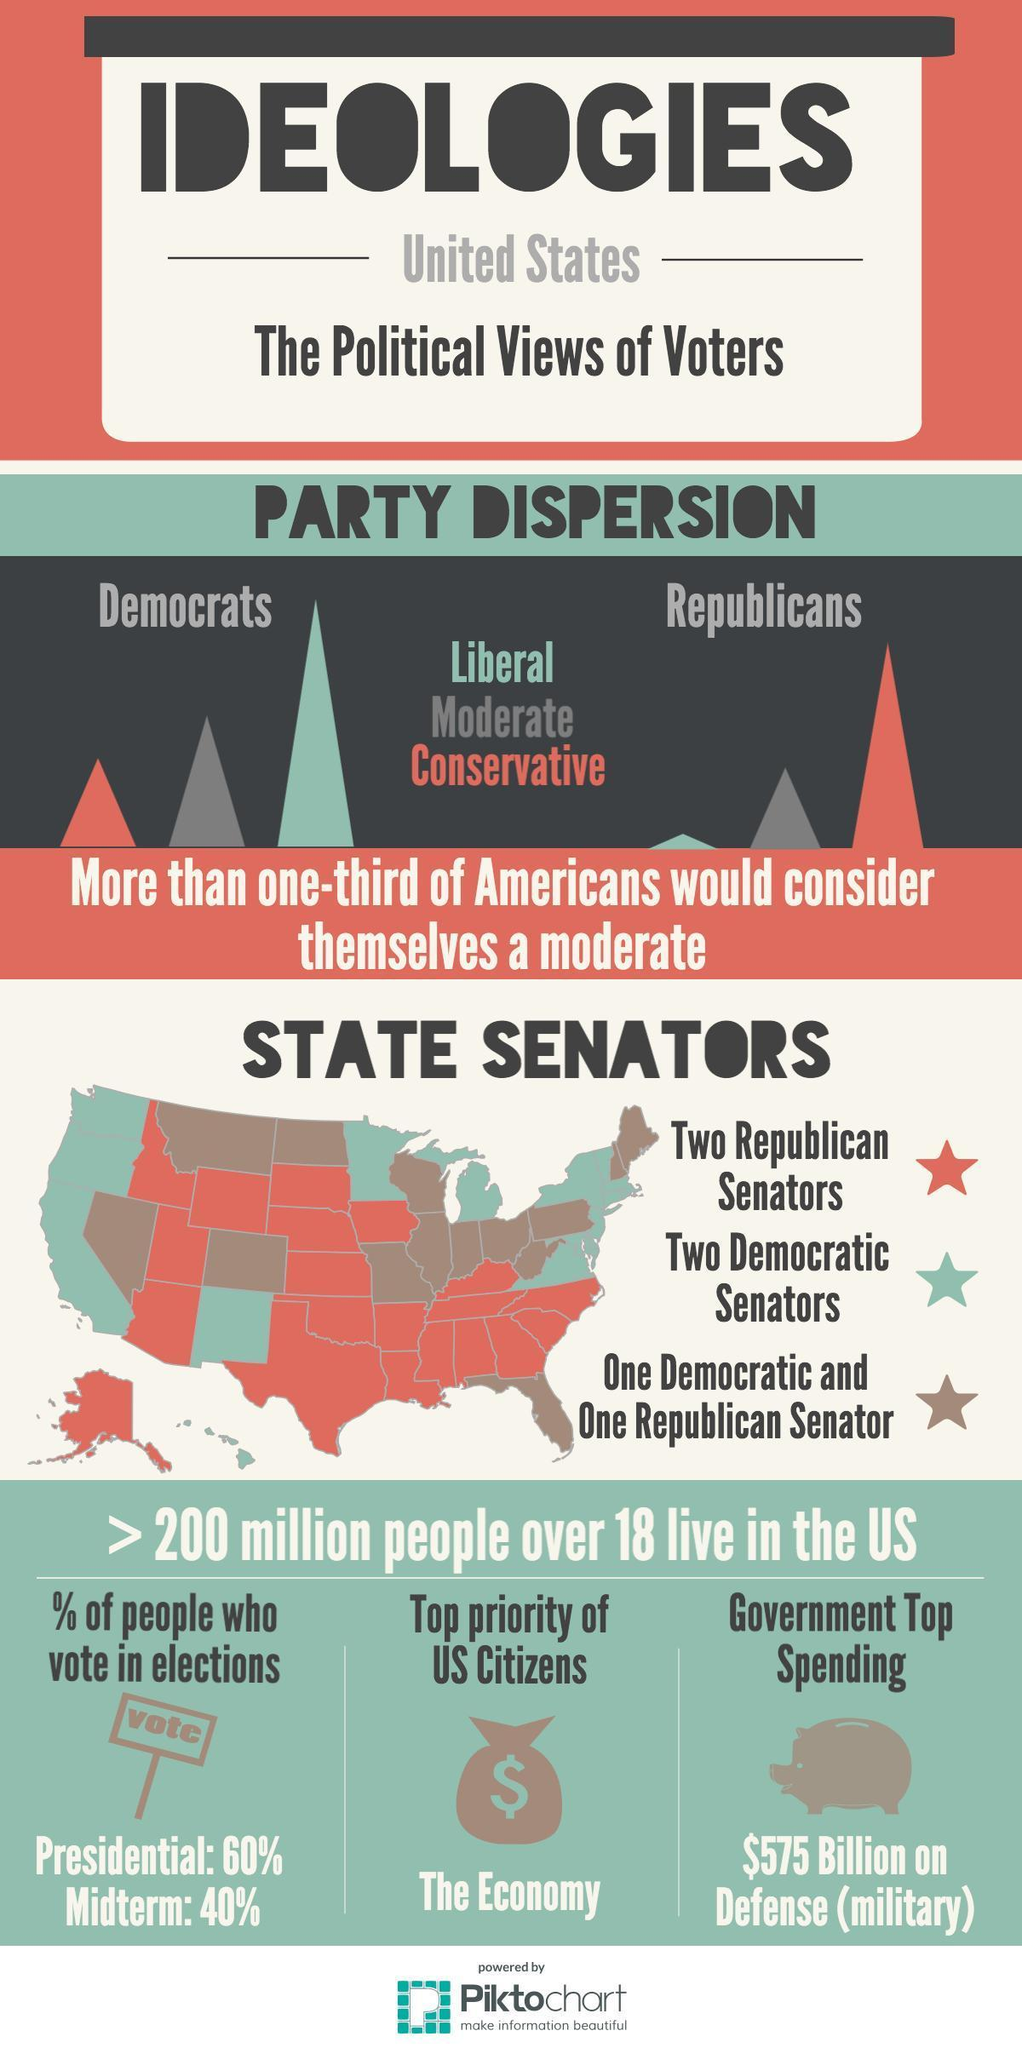Highlight a few significant elements in this photo. The Republican Party in the United States is led by conservatives who hold the most power among the party's members. Forty percent of the population participates in the Presidential election. The top priority of US citizens is the economy. The third-highest power among Republicans in the United States belongs to the Liberal party. The third-highest ranking Democratic party member in the United States is considered conservative. 